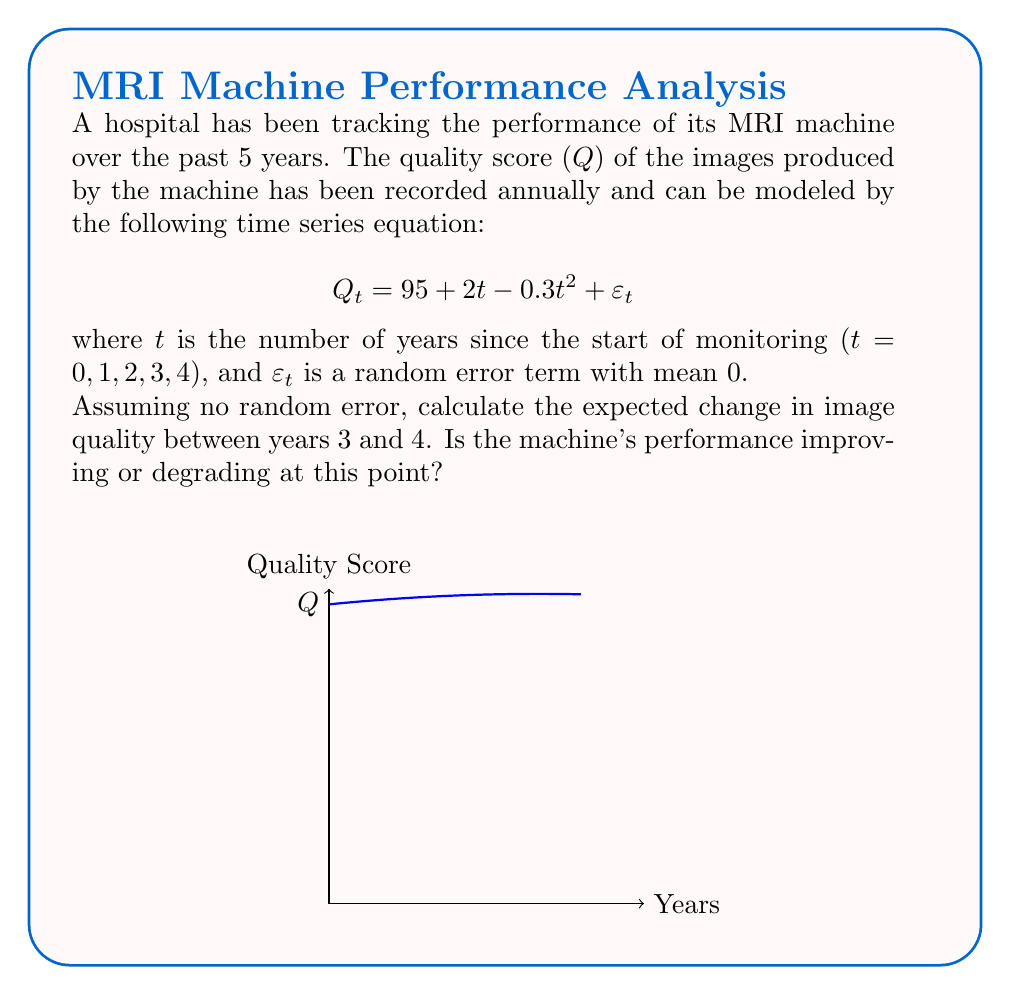Show me your answer to this math problem. To solve this problem, we need to follow these steps:

1) The given time series model is:
   $$Q_t = 95 + 2t - 0.3t^2 + \varepsilon_t$$

2) We're asked to ignore the random error term $\varepsilon_t$, so we'll work with:
   $$Q_t = 95 + 2t - 0.3t^2$$

3) To find the change in quality between years 3 and 4, we need to calculate $Q_4 - Q_3$:

   For t = 4:
   $$Q_4 = 95 + 2(4) - 0.3(4^2) = 95 + 8 - 4.8 = 98.2$$

   For t = 3:
   $$Q_3 = 95 + 2(3) - 0.3(3^2) = 95 + 6 - 2.7 = 98.3$$

4) The change in quality is:
   $$Q_4 - Q_3 = 98.2 - 98.3 = -0.1$$

5) To determine if the machine's performance is improving or degrading, we can look at the sign of this change. A negative value indicates a decrease in quality score, meaning the performance is degrading.

6) We can also confirm this by looking at the derivative of the quality function:
   $$\frac{dQ}{dt} = 2 - 0.6t$$
   At t = 3.5 (between years 3 and 4), this equals:
   $$2 - 0.6(3.5) = -0.1$$
   The negative value confirms that the quality is decreasing at this point.
Answer: -0.1; degrading 